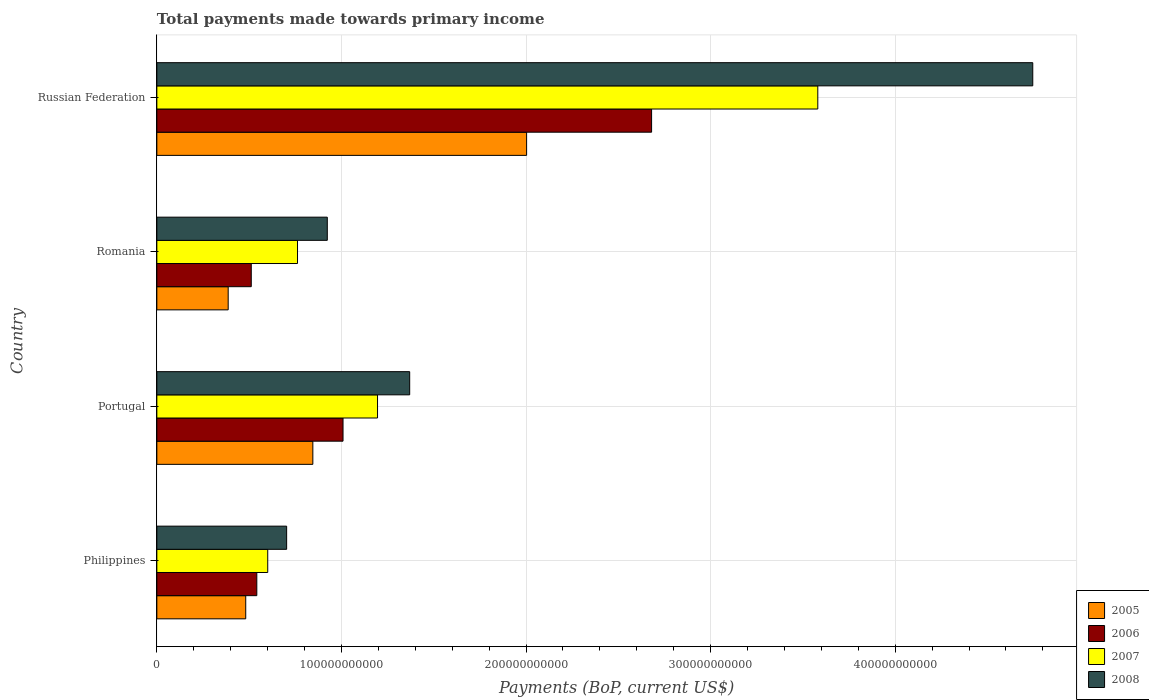How many different coloured bars are there?
Your answer should be compact. 4. Are the number of bars per tick equal to the number of legend labels?
Offer a terse response. Yes. Are the number of bars on each tick of the Y-axis equal?
Make the answer very short. Yes. How many bars are there on the 2nd tick from the bottom?
Your response must be concise. 4. In how many cases, is the number of bars for a given country not equal to the number of legend labels?
Offer a very short reply. 0. What is the total payments made towards primary income in 2008 in Russian Federation?
Your response must be concise. 4.75e+11. Across all countries, what is the maximum total payments made towards primary income in 2005?
Your response must be concise. 2.00e+11. Across all countries, what is the minimum total payments made towards primary income in 2005?
Your response must be concise. 3.86e+1. In which country was the total payments made towards primary income in 2008 maximum?
Ensure brevity in your answer.  Russian Federation. What is the total total payments made towards primary income in 2008 in the graph?
Your response must be concise. 7.74e+11. What is the difference between the total payments made towards primary income in 2008 in Philippines and that in Russian Federation?
Your response must be concise. -4.04e+11. What is the difference between the total payments made towards primary income in 2008 in Portugal and the total payments made towards primary income in 2007 in Philippines?
Offer a terse response. 7.69e+1. What is the average total payments made towards primary income in 2005 per country?
Your answer should be very brief. 9.29e+1. What is the difference between the total payments made towards primary income in 2005 and total payments made towards primary income in 2007 in Portugal?
Make the answer very short. -3.50e+1. What is the ratio of the total payments made towards primary income in 2006 in Romania to that in Russian Federation?
Your answer should be very brief. 0.19. What is the difference between the highest and the second highest total payments made towards primary income in 2008?
Give a very brief answer. 3.38e+11. What is the difference between the highest and the lowest total payments made towards primary income in 2007?
Offer a very short reply. 2.98e+11. Is it the case that in every country, the sum of the total payments made towards primary income in 2007 and total payments made towards primary income in 2006 is greater than the sum of total payments made towards primary income in 2008 and total payments made towards primary income in 2005?
Make the answer very short. No. Is it the case that in every country, the sum of the total payments made towards primary income in 2008 and total payments made towards primary income in 2005 is greater than the total payments made towards primary income in 2007?
Provide a short and direct response. Yes. How many bars are there?
Ensure brevity in your answer.  16. Are all the bars in the graph horizontal?
Make the answer very short. Yes. How many countries are there in the graph?
Provide a succinct answer. 4. What is the difference between two consecutive major ticks on the X-axis?
Ensure brevity in your answer.  1.00e+11. Does the graph contain any zero values?
Ensure brevity in your answer.  No. Where does the legend appear in the graph?
Keep it short and to the point. Bottom right. How are the legend labels stacked?
Your answer should be compact. Vertical. What is the title of the graph?
Your response must be concise. Total payments made towards primary income. Does "1990" appear as one of the legend labels in the graph?
Ensure brevity in your answer.  No. What is the label or title of the X-axis?
Make the answer very short. Payments (BoP, current US$). What is the label or title of the Y-axis?
Offer a terse response. Country. What is the Payments (BoP, current US$) in 2005 in Philippines?
Provide a succinct answer. 4.82e+1. What is the Payments (BoP, current US$) in 2006 in Philippines?
Provide a succinct answer. 5.42e+1. What is the Payments (BoP, current US$) in 2007 in Philippines?
Offer a very short reply. 6.01e+1. What is the Payments (BoP, current US$) of 2008 in Philippines?
Provide a succinct answer. 7.03e+1. What is the Payments (BoP, current US$) in 2005 in Portugal?
Ensure brevity in your answer.  8.45e+1. What is the Payments (BoP, current US$) of 2006 in Portugal?
Make the answer very short. 1.01e+11. What is the Payments (BoP, current US$) of 2007 in Portugal?
Ensure brevity in your answer.  1.20e+11. What is the Payments (BoP, current US$) of 2008 in Portugal?
Provide a short and direct response. 1.37e+11. What is the Payments (BoP, current US$) of 2005 in Romania?
Provide a short and direct response. 3.86e+1. What is the Payments (BoP, current US$) in 2006 in Romania?
Ensure brevity in your answer.  5.11e+1. What is the Payments (BoP, current US$) of 2007 in Romania?
Keep it short and to the point. 7.62e+1. What is the Payments (BoP, current US$) in 2008 in Romania?
Your response must be concise. 9.23e+1. What is the Payments (BoP, current US$) in 2005 in Russian Federation?
Make the answer very short. 2.00e+11. What is the Payments (BoP, current US$) of 2006 in Russian Federation?
Offer a very short reply. 2.68e+11. What is the Payments (BoP, current US$) of 2007 in Russian Federation?
Provide a short and direct response. 3.58e+11. What is the Payments (BoP, current US$) in 2008 in Russian Federation?
Offer a very short reply. 4.75e+11. Across all countries, what is the maximum Payments (BoP, current US$) of 2005?
Provide a succinct answer. 2.00e+11. Across all countries, what is the maximum Payments (BoP, current US$) in 2006?
Make the answer very short. 2.68e+11. Across all countries, what is the maximum Payments (BoP, current US$) in 2007?
Your response must be concise. 3.58e+11. Across all countries, what is the maximum Payments (BoP, current US$) in 2008?
Offer a very short reply. 4.75e+11. Across all countries, what is the minimum Payments (BoP, current US$) of 2005?
Make the answer very short. 3.86e+1. Across all countries, what is the minimum Payments (BoP, current US$) in 2006?
Your answer should be compact. 5.11e+1. Across all countries, what is the minimum Payments (BoP, current US$) in 2007?
Your answer should be very brief. 6.01e+1. Across all countries, what is the minimum Payments (BoP, current US$) in 2008?
Make the answer very short. 7.03e+1. What is the total Payments (BoP, current US$) in 2005 in the graph?
Your response must be concise. 3.72e+11. What is the total Payments (BoP, current US$) in 2006 in the graph?
Your answer should be very brief. 4.74e+11. What is the total Payments (BoP, current US$) of 2007 in the graph?
Keep it short and to the point. 6.14e+11. What is the total Payments (BoP, current US$) in 2008 in the graph?
Your response must be concise. 7.74e+11. What is the difference between the Payments (BoP, current US$) of 2005 in Philippines and that in Portugal?
Your answer should be very brief. -3.64e+1. What is the difference between the Payments (BoP, current US$) in 2006 in Philippines and that in Portugal?
Offer a very short reply. -4.67e+1. What is the difference between the Payments (BoP, current US$) of 2007 in Philippines and that in Portugal?
Keep it short and to the point. -5.95e+1. What is the difference between the Payments (BoP, current US$) in 2008 in Philippines and that in Portugal?
Make the answer very short. -6.67e+1. What is the difference between the Payments (BoP, current US$) of 2005 in Philippines and that in Romania?
Your answer should be compact. 9.51e+09. What is the difference between the Payments (BoP, current US$) in 2006 in Philippines and that in Romania?
Your answer should be compact. 3.01e+09. What is the difference between the Payments (BoP, current US$) of 2007 in Philippines and that in Romania?
Give a very brief answer. -1.61e+1. What is the difference between the Payments (BoP, current US$) in 2008 in Philippines and that in Romania?
Your answer should be very brief. -2.20e+1. What is the difference between the Payments (BoP, current US$) in 2005 in Philippines and that in Russian Federation?
Your answer should be compact. -1.52e+11. What is the difference between the Payments (BoP, current US$) of 2006 in Philippines and that in Russian Federation?
Provide a short and direct response. -2.14e+11. What is the difference between the Payments (BoP, current US$) of 2007 in Philippines and that in Russian Federation?
Your answer should be compact. -2.98e+11. What is the difference between the Payments (BoP, current US$) in 2008 in Philippines and that in Russian Federation?
Ensure brevity in your answer.  -4.04e+11. What is the difference between the Payments (BoP, current US$) of 2005 in Portugal and that in Romania?
Provide a short and direct response. 4.59e+1. What is the difference between the Payments (BoP, current US$) in 2006 in Portugal and that in Romania?
Your answer should be compact. 4.97e+1. What is the difference between the Payments (BoP, current US$) of 2007 in Portugal and that in Romania?
Ensure brevity in your answer.  4.34e+1. What is the difference between the Payments (BoP, current US$) of 2008 in Portugal and that in Romania?
Offer a very short reply. 4.46e+1. What is the difference between the Payments (BoP, current US$) in 2005 in Portugal and that in Russian Federation?
Your response must be concise. -1.16e+11. What is the difference between the Payments (BoP, current US$) of 2006 in Portugal and that in Russian Federation?
Give a very brief answer. -1.67e+11. What is the difference between the Payments (BoP, current US$) in 2007 in Portugal and that in Russian Federation?
Your answer should be very brief. -2.39e+11. What is the difference between the Payments (BoP, current US$) in 2008 in Portugal and that in Russian Federation?
Provide a short and direct response. -3.38e+11. What is the difference between the Payments (BoP, current US$) in 2005 in Romania and that in Russian Federation?
Provide a short and direct response. -1.62e+11. What is the difference between the Payments (BoP, current US$) of 2006 in Romania and that in Russian Federation?
Provide a succinct answer. -2.17e+11. What is the difference between the Payments (BoP, current US$) of 2007 in Romania and that in Russian Federation?
Make the answer very short. -2.82e+11. What is the difference between the Payments (BoP, current US$) of 2008 in Romania and that in Russian Federation?
Make the answer very short. -3.82e+11. What is the difference between the Payments (BoP, current US$) of 2005 in Philippines and the Payments (BoP, current US$) of 2006 in Portugal?
Your answer should be compact. -5.27e+1. What is the difference between the Payments (BoP, current US$) in 2005 in Philippines and the Payments (BoP, current US$) in 2007 in Portugal?
Offer a terse response. -7.14e+1. What is the difference between the Payments (BoP, current US$) in 2005 in Philippines and the Payments (BoP, current US$) in 2008 in Portugal?
Offer a terse response. -8.88e+1. What is the difference between the Payments (BoP, current US$) of 2006 in Philippines and the Payments (BoP, current US$) of 2007 in Portugal?
Your answer should be compact. -6.54e+1. What is the difference between the Payments (BoP, current US$) in 2006 in Philippines and the Payments (BoP, current US$) in 2008 in Portugal?
Your response must be concise. -8.28e+1. What is the difference between the Payments (BoP, current US$) of 2007 in Philippines and the Payments (BoP, current US$) of 2008 in Portugal?
Provide a short and direct response. -7.69e+1. What is the difference between the Payments (BoP, current US$) of 2005 in Philippines and the Payments (BoP, current US$) of 2006 in Romania?
Give a very brief answer. -2.99e+09. What is the difference between the Payments (BoP, current US$) in 2005 in Philippines and the Payments (BoP, current US$) in 2007 in Romania?
Offer a very short reply. -2.80e+1. What is the difference between the Payments (BoP, current US$) of 2005 in Philippines and the Payments (BoP, current US$) of 2008 in Romania?
Provide a short and direct response. -4.42e+1. What is the difference between the Payments (BoP, current US$) in 2006 in Philippines and the Payments (BoP, current US$) in 2007 in Romania?
Ensure brevity in your answer.  -2.21e+1. What is the difference between the Payments (BoP, current US$) of 2006 in Philippines and the Payments (BoP, current US$) of 2008 in Romania?
Provide a short and direct response. -3.82e+1. What is the difference between the Payments (BoP, current US$) in 2007 in Philippines and the Payments (BoP, current US$) in 2008 in Romania?
Keep it short and to the point. -3.23e+1. What is the difference between the Payments (BoP, current US$) in 2005 in Philippines and the Payments (BoP, current US$) in 2006 in Russian Federation?
Your answer should be very brief. -2.20e+11. What is the difference between the Payments (BoP, current US$) of 2005 in Philippines and the Payments (BoP, current US$) of 2007 in Russian Federation?
Provide a succinct answer. -3.10e+11. What is the difference between the Payments (BoP, current US$) of 2005 in Philippines and the Payments (BoP, current US$) of 2008 in Russian Federation?
Offer a terse response. -4.26e+11. What is the difference between the Payments (BoP, current US$) of 2006 in Philippines and the Payments (BoP, current US$) of 2007 in Russian Federation?
Your answer should be compact. -3.04e+11. What is the difference between the Payments (BoP, current US$) of 2006 in Philippines and the Payments (BoP, current US$) of 2008 in Russian Federation?
Make the answer very short. -4.20e+11. What is the difference between the Payments (BoP, current US$) in 2007 in Philippines and the Payments (BoP, current US$) in 2008 in Russian Federation?
Make the answer very short. -4.14e+11. What is the difference between the Payments (BoP, current US$) of 2005 in Portugal and the Payments (BoP, current US$) of 2006 in Romania?
Give a very brief answer. 3.34e+1. What is the difference between the Payments (BoP, current US$) in 2005 in Portugal and the Payments (BoP, current US$) in 2007 in Romania?
Provide a succinct answer. 8.30e+09. What is the difference between the Payments (BoP, current US$) in 2005 in Portugal and the Payments (BoP, current US$) in 2008 in Romania?
Your response must be concise. -7.83e+09. What is the difference between the Payments (BoP, current US$) of 2006 in Portugal and the Payments (BoP, current US$) of 2007 in Romania?
Your answer should be very brief. 2.47e+1. What is the difference between the Payments (BoP, current US$) of 2006 in Portugal and the Payments (BoP, current US$) of 2008 in Romania?
Your answer should be compact. 8.52e+09. What is the difference between the Payments (BoP, current US$) in 2007 in Portugal and the Payments (BoP, current US$) in 2008 in Romania?
Provide a succinct answer. 2.72e+1. What is the difference between the Payments (BoP, current US$) of 2005 in Portugal and the Payments (BoP, current US$) of 2006 in Russian Federation?
Provide a succinct answer. -1.84e+11. What is the difference between the Payments (BoP, current US$) in 2005 in Portugal and the Payments (BoP, current US$) in 2007 in Russian Federation?
Keep it short and to the point. -2.74e+11. What is the difference between the Payments (BoP, current US$) in 2005 in Portugal and the Payments (BoP, current US$) in 2008 in Russian Federation?
Provide a succinct answer. -3.90e+11. What is the difference between the Payments (BoP, current US$) of 2006 in Portugal and the Payments (BoP, current US$) of 2007 in Russian Federation?
Keep it short and to the point. -2.57e+11. What is the difference between the Payments (BoP, current US$) of 2006 in Portugal and the Payments (BoP, current US$) of 2008 in Russian Federation?
Give a very brief answer. -3.74e+11. What is the difference between the Payments (BoP, current US$) of 2007 in Portugal and the Payments (BoP, current US$) of 2008 in Russian Federation?
Give a very brief answer. -3.55e+11. What is the difference between the Payments (BoP, current US$) of 2005 in Romania and the Payments (BoP, current US$) of 2006 in Russian Federation?
Ensure brevity in your answer.  -2.29e+11. What is the difference between the Payments (BoP, current US$) of 2005 in Romania and the Payments (BoP, current US$) of 2007 in Russian Federation?
Offer a very short reply. -3.19e+11. What is the difference between the Payments (BoP, current US$) in 2005 in Romania and the Payments (BoP, current US$) in 2008 in Russian Federation?
Your answer should be compact. -4.36e+11. What is the difference between the Payments (BoP, current US$) in 2006 in Romania and the Payments (BoP, current US$) in 2007 in Russian Federation?
Offer a terse response. -3.07e+11. What is the difference between the Payments (BoP, current US$) of 2006 in Romania and the Payments (BoP, current US$) of 2008 in Russian Federation?
Give a very brief answer. -4.23e+11. What is the difference between the Payments (BoP, current US$) of 2007 in Romania and the Payments (BoP, current US$) of 2008 in Russian Federation?
Make the answer very short. -3.98e+11. What is the average Payments (BoP, current US$) in 2005 per country?
Your response must be concise. 9.29e+1. What is the average Payments (BoP, current US$) of 2006 per country?
Offer a terse response. 1.19e+11. What is the average Payments (BoP, current US$) in 2007 per country?
Ensure brevity in your answer.  1.53e+11. What is the average Payments (BoP, current US$) of 2008 per country?
Provide a succinct answer. 1.94e+11. What is the difference between the Payments (BoP, current US$) in 2005 and Payments (BoP, current US$) in 2006 in Philippines?
Provide a short and direct response. -6.00e+09. What is the difference between the Payments (BoP, current US$) of 2005 and Payments (BoP, current US$) of 2007 in Philippines?
Provide a succinct answer. -1.19e+1. What is the difference between the Payments (BoP, current US$) of 2005 and Payments (BoP, current US$) of 2008 in Philippines?
Provide a short and direct response. -2.22e+1. What is the difference between the Payments (BoP, current US$) of 2006 and Payments (BoP, current US$) of 2007 in Philippines?
Provide a succinct answer. -5.92e+09. What is the difference between the Payments (BoP, current US$) in 2006 and Payments (BoP, current US$) in 2008 in Philippines?
Your answer should be very brief. -1.62e+1. What is the difference between the Payments (BoP, current US$) in 2007 and Payments (BoP, current US$) in 2008 in Philippines?
Your response must be concise. -1.02e+1. What is the difference between the Payments (BoP, current US$) in 2005 and Payments (BoP, current US$) in 2006 in Portugal?
Make the answer very short. -1.64e+1. What is the difference between the Payments (BoP, current US$) of 2005 and Payments (BoP, current US$) of 2007 in Portugal?
Your answer should be compact. -3.50e+1. What is the difference between the Payments (BoP, current US$) of 2005 and Payments (BoP, current US$) of 2008 in Portugal?
Provide a short and direct response. -5.25e+1. What is the difference between the Payments (BoP, current US$) of 2006 and Payments (BoP, current US$) of 2007 in Portugal?
Provide a succinct answer. -1.87e+1. What is the difference between the Payments (BoP, current US$) of 2006 and Payments (BoP, current US$) of 2008 in Portugal?
Your response must be concise. -3.61e+1. What is the difference between the Payments (BoP, current US$) of 2007 and Payments (BoP, current US$) of 2008 in Portugal?
Give a very brief answer. -1.74e+1. What is the difference between the Payments (BoP, current US$) of 2005 and Payments (BoP, current US$) of 2006 in Romania?
Ensure brevity in your answer.  -1.25e+1. What is the difference between the Payments (BoP, current US$) of 2005 and Payments (BoP, current US$) of 2007 in Romania?
Your answer should be very brief. -3.76e+1. What is the difference between the Payments (BoP, current US$) in 2005 and Payments (BoP, current US$) in 2008 in Romania?
Ensure brevity in your answer.  -5.37e+1. What is the difference between the Payments (BoP, current US$) of 2006 and Payments (BoP, current US$) of 2007 in Romania?
Offer a terse response. -2.51e+1. What is the difference between the Payments (BoP, current US$) in 2006 and Payments (BoP, current US$) in 2008 in Romania?
Your response must be concise. -4.12e+1. What is the difference between the Payments (BoP, current US$) in 2007 and Payments (BoP, current US$) in 2008 in Romania?
Provide a short and direct response. -1.61e+1. What is the difference between the Payments (BoP, current US$) of 2005 and Payments (BoP, current US$) of 2006 in Russian Federation?
Your answer should be compact. -6.77e+1. What is the difference between the Payments (BoP, current US$) in 2005 and Payments (BoP, current US$) in 2007 in Russian Federation?
Your answer should be compact. -1.58e+11. What is the difference between the Payments (BoP, current US$) of 2005 and Payments (BoP, current US$) of 2008 in Russian Federation?
Offer a terse response. -2.74e+11. What is the difference between the Payments (BoP, current US$) in 2006 and Payments (BoP, current US$) in 2007 in Russian Federation?
Offer a terse response. -9.00e+1. What is the difference between the Payments (BoP, current US$) in 2006 and Payments (BoP, current US$) in 2008 in Russian Federation?
Provide a short and direct response. -2.06e+11. What is the difference between the Payments (BoP, current US$) in 2007 and Payments (BoP, current US$) in 2008 in Russian Federation?
Provide a short and direct response. -1.16e+11. What is the ratio of the Payments (BoP, current US$) of 2005 in Philippines to that in Portugal?
Give a very brief answer. 0.57. What is the ratio of the Payments (BoP, current US$) of 2006 in Philippines to that in Portugal?
Your answer should be compact. 0.54. What is the ratio of the Payments (BoP, current US$) of 2007 in Philippines to that in Portugal?
Make the answer very short. 0.5. What is the ratio of the Payments (BoP, current US$) in 2008 in Philippines to that in Portugal?
Give a very brief answer. 0.51. What is the ratio of the Payments (BoP, current US$) in 2005 in Philippines to that in Romania?
Make the answer very short. 1.25. What is the ratio of the Payments (BoP, current US$) in 2006 in Philippines to that in Romania?
Keep it short and to the point. 1.06. What is the ratio of the Payments (BoP, current US$) of 2007 in Philippines to that in Romania?
Offer a very short reply. 0.79. What is the ratio of the Payments (BoP, current US$) in 2008 in Philippines to that in Romania?
Provide a short and direct response. 0.76. What is the ratio of the Payments (BoP, current US$) of 2005 in Philippines to that in Russian Federation?
Your answer should be compact. 0.24. What is the ratio of the Payments (BoP, current US$) in 2006 in Philippines to that in Russian Federation?
Offer a terse response. 0.2. What is the ratio of the Payments (BoP, current US$) in 2007 in Philippines to that in Russian Federation?
Your answer should be compact. 0.17. What is the ratio of the Payments (BoP, current US$) in 2008 in Philippines to that in Russian Federation?
Provide a succinct answer. 0.15. What is the ratio of the Payments (BoP, current US$) in 2005 in Portugal to that in Romania?
Offer a very short reply. 2.19. What is the ratio of the Payments (BoP, current US$) in 2006 in Portugal to that in Romania?
Offer a terse response. 1.97. What is the ratio of the Payments (BoP, current US$) in 2007 in Portugal to that in Romania?
Your response must be concise. 1.57. What is the ratio of the Payments (BoP, current US$) of 2008 in Portugal to that in Romania?
Offer a terse response. 1.48. What is the ratio of the Payments (BoP, current US$) of 2005 in Portugal to that in Russian Federation?
Your response must be concise. 0.42. What is the ratio of the Payments (BoP, current US$) in 2006 in Portugal to that in Russian Federation?
Ensure brevity in your answer.  0.38. What is the ratio of the Payments (BoP, current US$) in 2007 in Portugal to that in Russian Federation?
Offer a terse response. 0.33. What is the ratio of the Payments (BoP, current US$) in 2008 in Portugal to that in Russian Federation?
Your answer should be very brief. 0.29. What is the ratio of the Payments (BoP, current US$) in 2005 in Romania to that in Russian Federation?
Ensure brevity in your answer.  0.19. What is the ratio of the Payments (BoP, current US$) of 2006 in Romania to that in Russian Federation?
Make the answer very short. 0.19. What is the ratio of the Payments (BoP, current US$) in 2007 in Romania to that in Russian Federation?
Give a very brief answer. 0.21. What is the ratio of the Payments (BoP, current US$) of 2008 in Romania to that in Russian Federation?
Offer a terse response. 0.19. What is the difference between the highest and the second highest Payments (BoP, current US$) of 2005?
Give a very brief answer. 1.16e+11. What is the difference between the highest and the second highest Payments (BoP, current US$) in 2006?
Your answer should be very brief. 1.67e+11. What is the difference between the highest and the second highest Payments (BoP, current US$) in 2007?
Your response must be concise. 2.39e+11. What is the difference between the highest and the second highest Payments (BoP, current US$) of 2008?
Keep it short and to the point. 3.38e+11. What is the difference between the highest and the lowest Payments (BoP, current US$) in 2005?
Give a very brief answer. 1.62e+11. What is the difference between the highest and the lowest Payments (BoP, current US$) of 2006?
Ensure brevity in your answer.  2.17e+11. What is the difference between the highest and the lowest Payments (BoP, current US$) of 2007?
Give a very brief answer. 2.98e+11. What is the difference between the highest and the lowest Payments (BoP, current US$) of 2008?
Offer a terse response. 4.04e+11. 